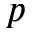<formula> <loc_0><loc_0><loc_500><loc_500>p</formula> 